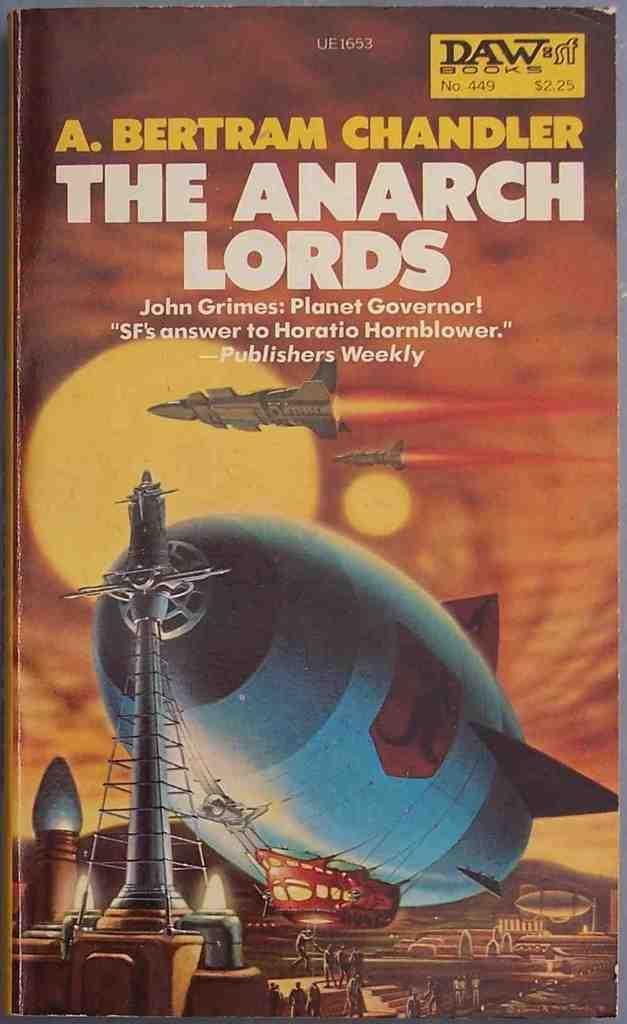<image>
Provide a brief description of the given image. A book by A. Bertram Chandler titled The Anarch Lords. 